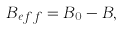Convert formula to latex. <formula><loc_0><loc_0><loc_500><loc_500>B _ { e f f } = B _ { 0 } - B ,</formula> 